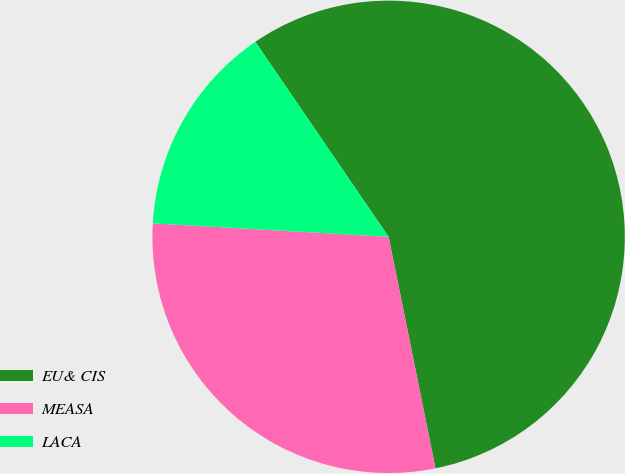Convert chart to OTSL. <chart><loc_0><loc_0><loc_500><loc_500><pie_chart><fcel>EU& CIS<fcel>MEASA<fcel>LACA<nl><fcel>56.36%<fcel>29.09%<fcel>14.55%<nl></chart> 